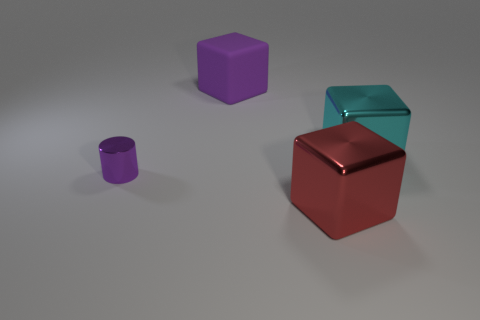There is a cube that is behind the cyan block; is it the same color as the small shiny object in front of the large cyan metal cube?
Offer a very short reply. Yes. Is there a large cyan thing made of the same material as the small purple cylinder?
Offer a very short reply. Yes. What number of cyan things are either large cubes or metal cubes?
Offer a very short reply. 1. Is the number of large metallic blocks that are to the right of the tiny metallic object greater than the number of tiny purple objects?
Offer a terse response. Yes. Is the purple matte object the same size as the red metal block?
Give a very brief answer. Yes. What color is the tiny cylinder that is made of the same material as the big red object?
Offer a terse response. Purple. What is the shape of the big rubber thing that is the same color as the small shiny cylinder?
Provide a short and direct response. Cube. Are there the same number of large purple matte things behind the large cyan shiny block and purple cubes behind the purple rubber object?
Offer a terse response. No. What shape is the large shiny thing behind the large block in front of the tiny purple metallic cylinder?
Provide a succinct answer. Cube. There is a big cyan object that is the same shape as the large red metallic thing; what is it made of?
Provide a short and direct response. Metal. 